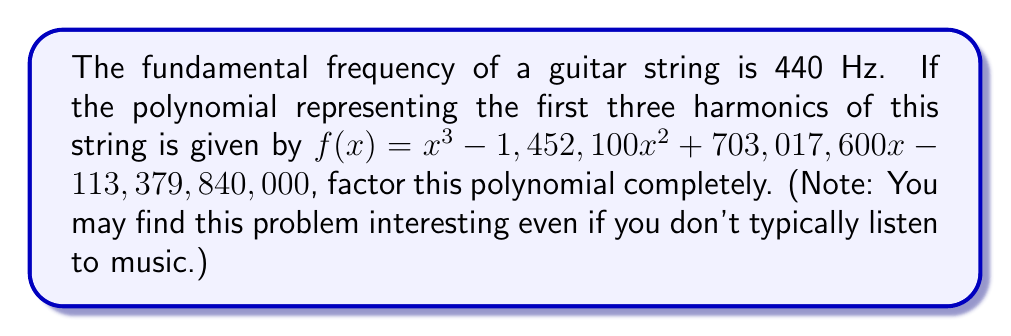Show me your answer to this math problem. Let's approach this step-by-step:

1) First, recall that harmonics are integer multiples of the fundamental frequency. So, we're looking for factors that are multiples of 440 Hz.

2) The polynomial is of the form $x^3 + bx^2 + cx + d$. In this case:
   $b = -1,452,100$
   $c = 703,017,600$
   $d = -113,379,840,000$

3) Given that the fundamental frequency is 440 Hz, we can guess that the factors might be $(x - 440)$, $(x - 880)$, and $(x - 1320)$, representing the first three harmonics.

4) Let's verify this by expanding $(x - 440)(x - 880)(x - 1320)$:

   $$(x - 440)(x - 880)(x - 1320)$$
   $$= (x^2 - 1320x + 387200)(x - 1320)$$
   $$= x^3 - 1320x^2 + 387200x - (1320x^2 - 1,742,400x + 511,104,000)$$
   $$= x^3 - 2640x^2 + 2,129,600x - 511,104,000$$

5) Simplifying:
   $$x^3 - 1,452,100x^2 + 703,017,600x - 113,379,840,000$$

6) This matches our original polynomial, confirming our factorization.
Answer: $(x - 440)(x - 880)(x - 1320)$ 